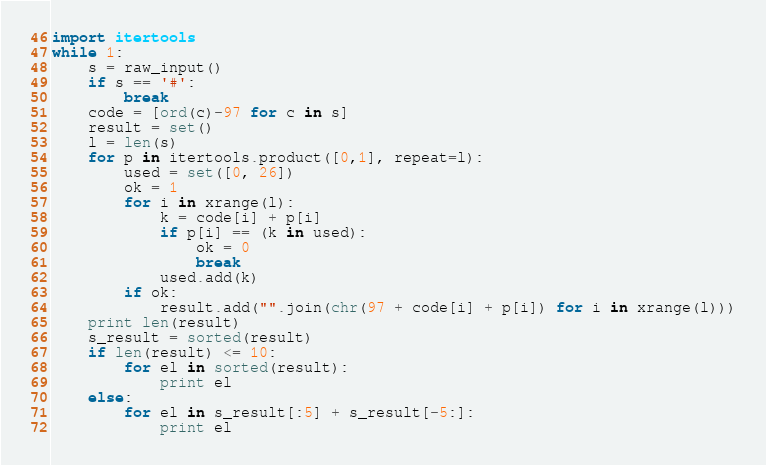Convert code to text. <code><loc_0><loc_0><loc_500><loc_500><_Python_>import itertools
while 1:
    s = raw_input()
    if s == '#':
        break
    code = [ord(c)-97 for c in s]
    result = set()
    l = len(s)
    for p in itertools.product([0,1], repeat=l):
        used = set([0, 26])
        ok = 1
        for i in xrange(l):
            k = code[i] + p[i]
            if p[i] == (k in used):
                ok = 0
                break
            used.add(k)
        if ok:
            result.add("".join(chr(97 + code[i] + p[i]) for i in xrange(l)))
    print len(result)
    s_result = sorted(result)
    if len(result) <= 10:
        for el in sorted(result):
            print el
    else:
        for el in s_result[:5] + s_result[-5:]:
            print el</code> 